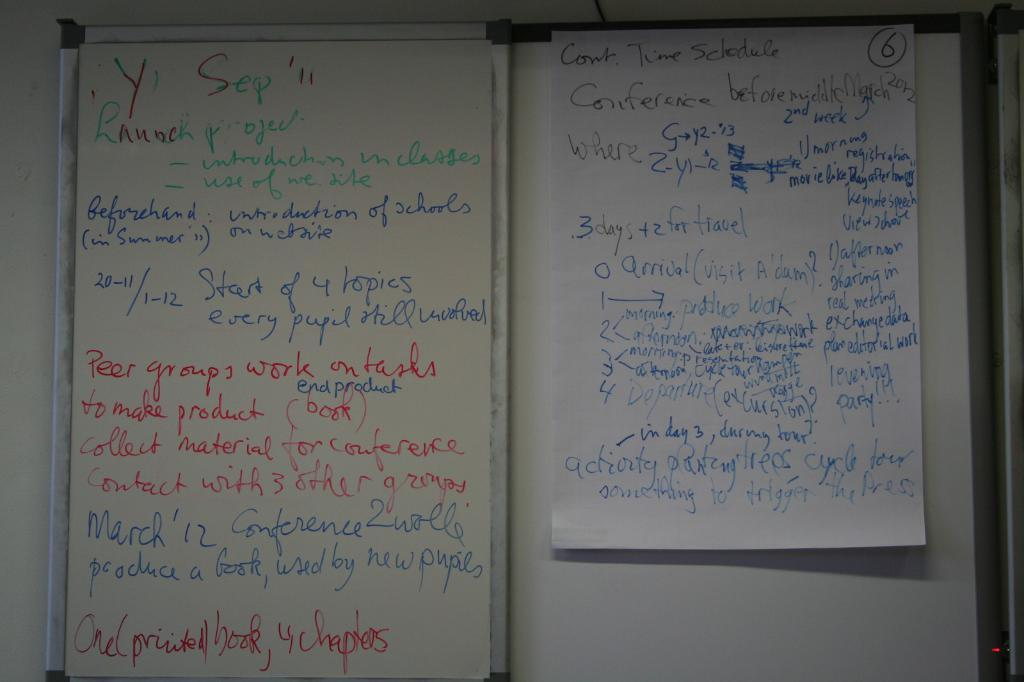Provide a one-sentence caption for the provided image. A list of of things that needs to be done starts with launch project. 